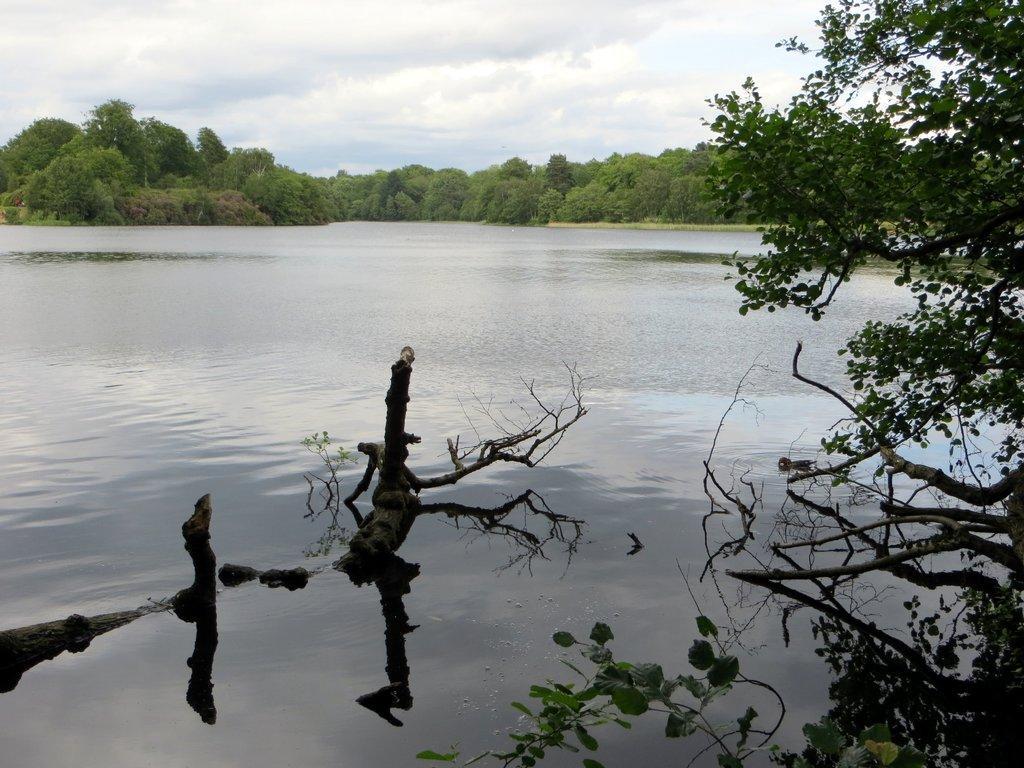Can you describe this image briefly? In this image we can see sky with clouds, trees and a lake. 